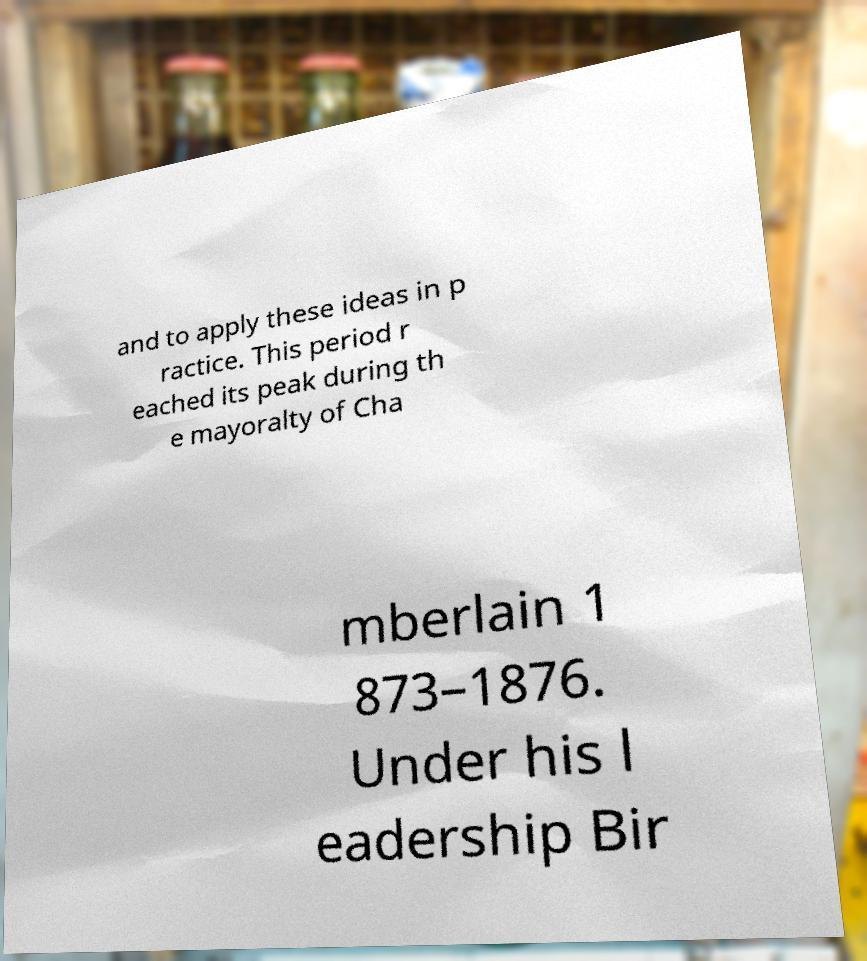Can you read and provide the text displayed in the image?This photo seems to have some interesting text. Can you extract and type it out for me? and to apply these ideas in p ractice. This period r eached its peak during th e mayoralty of Cha mberlain 1 873–1876. Under his l eadership Bir 